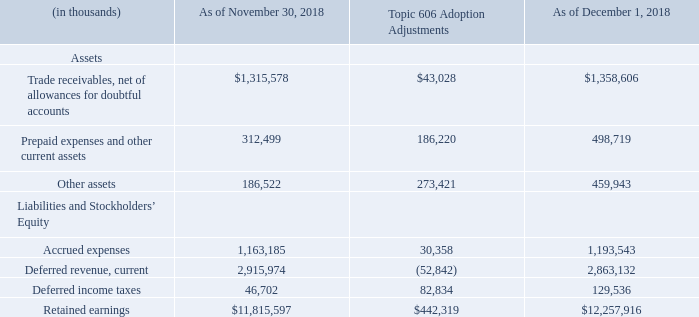Recently Adopted Accounting Guidance
On May 28, 2014, the Financial Accounting Standards Board (“FASB”) issued Accounting Standards Update (“ASU”) No. 2014-09, Revenue from Contracts with Customers, Topic 606, requiring an entity to recognize the amount of revenue to which it expects to be entitled for the transfer of promised goods or services to customers. Topic 606 also includes Subtopic 340-40, Other Assets and Deferred Costs - Contracts with Customers, which requires the capitalization of incremental costs to obtain a contract with a customer. The new revenue standard replaces most existing revenue recognition guidance in GAAP and permits the use of either the full retrospective or modified retrospective transition method.
On December 1, 2018, the beginning of our fiscal year 2019, we adopted the requirements of the new revenue standard utilizing the modified retrospective method of transition. Prior period information has not been restated and continues to be reported under the accounting standard in effect for those periods. We applied the new revenue standard to contracts that were not completed as of the adoption date, consistent with the transition guidance. Further, adoption of the new revenue standard resulted in changes to our accounting policies for revenue recognition and sales commissions as detailed below.
We recognized the following cumulative effects of initially applying the new revenue standard as of December 1, 2018
Below is a summary of the adoption impacts of the new revenue standard:
We capitalized $413.2 million of contract acquisition costs comprised of sales and partner commission costs at adoption date (included in prepaid expenses and other current assets for the current portion and other assets for the long-term portion), with a corresponding adjustment to retained earnings. We are amortizing these costs over their respective expected period of benefit.
Revenue for certain contracts that were previously deferred would have been recognized in periods prior to adoption under the new standard. Upon adoption, we recorded the following adjustments to our beginning balances to reflect the amount of revenue that will no longer be recognized in future periods for such contracts: an increase in unbilled receivables (included in trade receivables, net) of $24.8 million, an increase in contract assets (included in prepaid expenses and other current assets for the current portion and other assets for the long-term portion) of $46.4 million and a decrease in deferred revenue of $52.8 million, with corresponding adjustments to retained earnings.
We recorded an increase to our opening deferred income tax liability of $82.8 million, with a corresponding adjustment to retained earnings, to record the tax effect of the above adjustments.
Further, we had other impacts to various accounts which resulted to an immaterial net reduction to our retained earnings.
What does topic 606 require a company to do? Requiring an entity to recognize the amount of revenue to which it expects to be entitled for the transfer of promised goods or services to customers., requires the capitalization of incremental costs to obtain a contract with a customer. When did the company adopt the new revenue standard requirements? December 1, 2018. How much was the Trade receivables, net of allowances for doubtful accounts changed by Topic 606?
Answer scale should be: percent. 43,028/1,315,578 
Answer: 3.27. What is the total assets as of November 30 2018?
Answer scale should be: thousand. 1,315,578 + 312,499 + 186,522
Answer: 1814599. What is the value of capitalised contract acquisition costs? $413.2 million. After the Topic 606 adjustments, what is the percentage change in deferred revenue, current? 
Answer scale should be: percent. -52,842/2,863,132 
Answer: -1.85. 